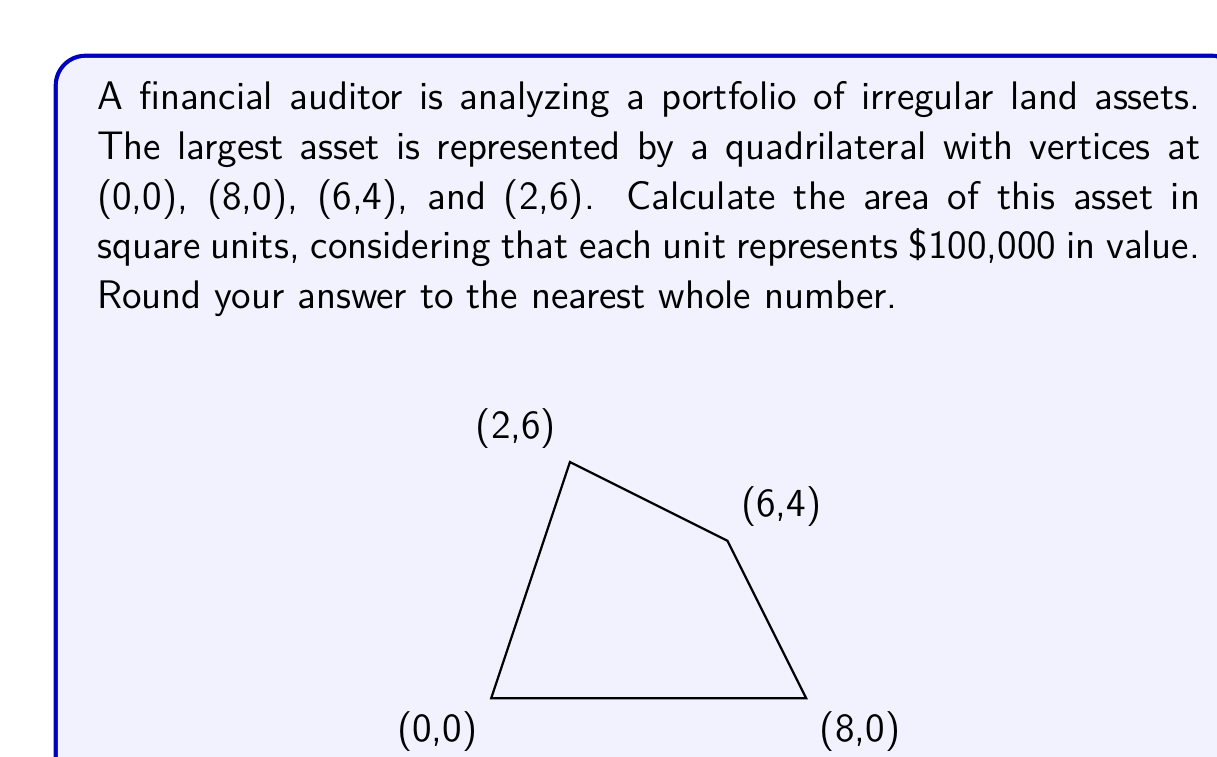What is the answer to this math problem? To calculate the area of this irregular quadrilateral, we can use the following steps:

1) Divide the quadrilateral into two triangles by drawing a diagonal from (0,0) to (6,4).

2) Calculate the area of each triangle using the formula:
   $$A = \frac{1}{2}|x_1(y_2 - y_3) + x_2(y_3 - y_1) + x_3(y_1 - y_2)|$$

3) For Triangle 1 (0,0), (8,0), (6,4):
   $$A_1 = \frac{1}{2}|0(0 - 4) + 8(4 - 0) + 6(0 - 0)| = \frac{1}{2}(32) = 16$$

4) For Triangle 2 (0,0), (6,4), (2,6):
   $$A_2 = \frac{1}{2}|0(4 - 6) + 6(6 - 0) + 2(0 - 4)| = \frac{1}{2}(28) = 14$$

5) The total area is the sum of these two triangles:
   $$A_{total} = A_1 + A_2 = 16 + 14 = 30$$ square units

6) Since each unit represents $100,000, the total value is:
   $$30 * $100,000 = $3,000,000$$

Therefore, the area of the asset is 30 square units, representing a value of $3,000,000.
Answer: 30 square units ($3,000,000) 